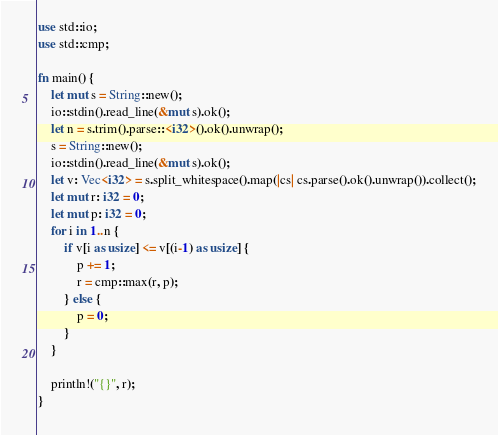Convert code to text. <code><loc_0><loc_0><loc_500><loc_500><_Rust_>use std::io;
use std::cmp;

fn main() {
    let mut s = String::new();
    io::stdin().read_line(&mut s).ok();
    let n = s.trim().parse::<i32>().ok().unwrap();
    s = String::new();
    io::stdin().read_line(&mut s).ok();
    let v: Vec<i32> = s.split_whitespace().map(|cs| cs.parse().ok().unwrap()).collect();
    let mut r: i32 = 0;
    let mut p: i32 = 0;
    for i in 1..n {
        if v[i as usize] <= v[(i-1) as usize] {
            p += 1;
            r = cmp::max(r, p);
        } else {
            p = 0;
        }
    }

    println!("{}", r);
}</code> 